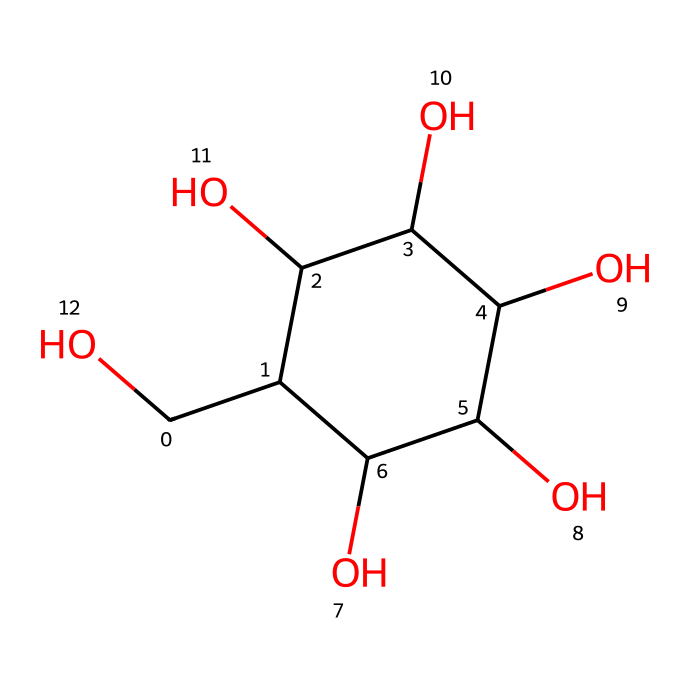What is the name of this chemical? The SMILES representation indicates that this chemical is a type of sugar, specifically glucose, which is commonly found in sports drinks.
Answer: glucose How many carbon atoms are in this structure? By analyzing the SMILES, we can count the distinct carbon (C) atoms, which totals six in the structure of glucose.
Answer: six How many hydroxyl (–OH) groups are present? Observing the structure, we note that there are five hydroxyl (–OH) groups attached to the carbon chain in glucose.
Answer: five What type of carbohydrate is glucose classified as? Glucose is classified as a monosaccharide, which is a simple sugar and a fundamental building block of carbohydrates.
Answer: monosaccharide What is the total number of hydrogen atoms in glucose? Each carbon in glucose typically bonds with enough hydrogen atoms to satisfy the tetravalent nature of carbon; in this case, there are 12 hydrogen atoms based on the structure.
Answer: twelve Why is glucose important in sports drinks? Glucose provides a quick source of energy, as it rapidly enters the bloodstream, making it essential for hydration and energy replenishment during physical activity.
Answer: energy source 